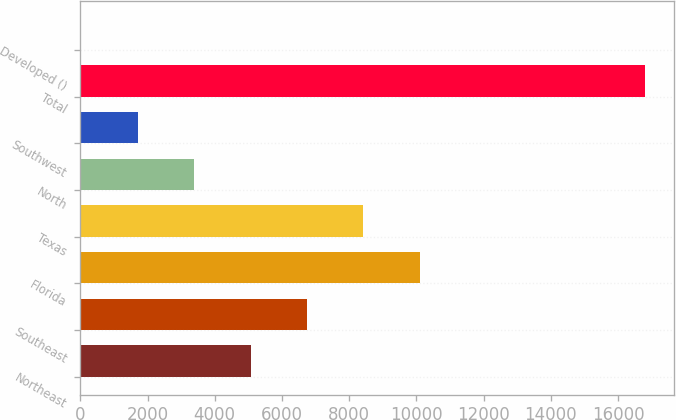Convert chart. <chart><loc_0><loc_0><loc_500><loc_500><bar_chart><fcel>Northeast<fcel>Southeast<fcel>Florida<fcel>Texas<fcel>North<fcel>Southwest<fcel>Total<fcel>Developed ()<nl><fcel>5068.3<fcel>6746.4<fcel>10102.6<fcel>8424.5<fcel>3390.2<fcel>1712.1<fcel>16815<fcel>34<nl></chart> 